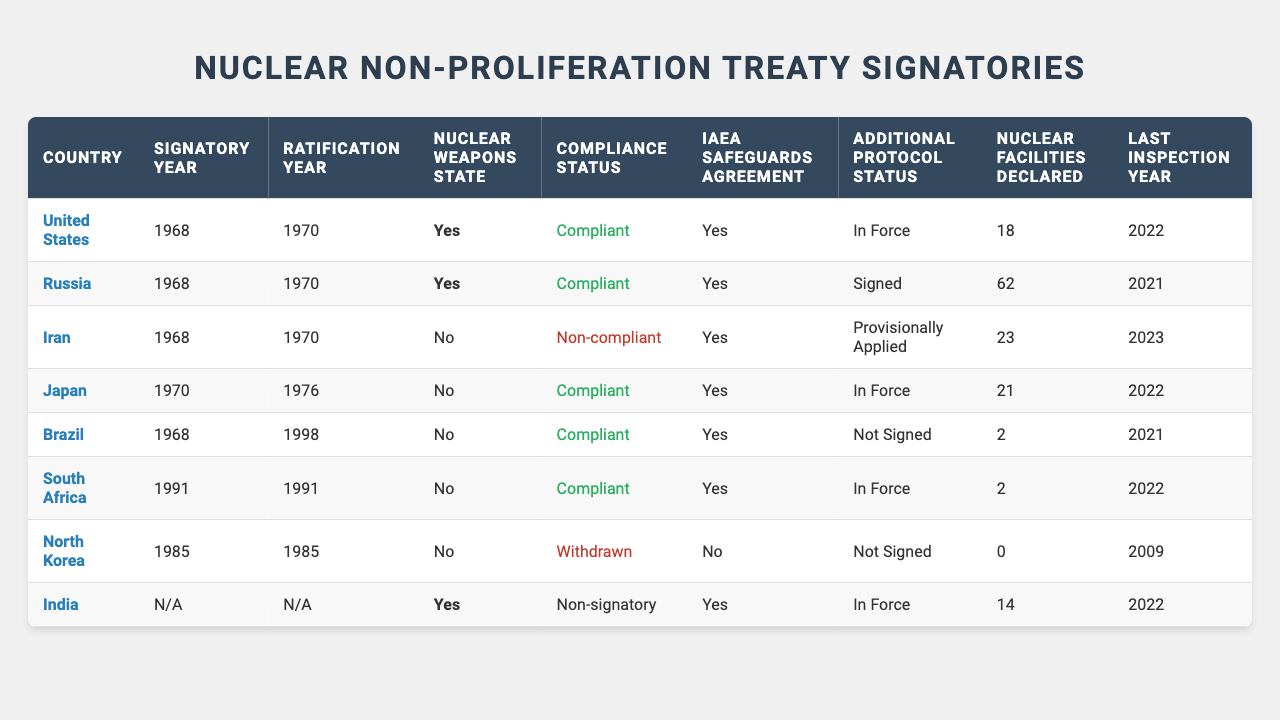What year did North Korea sign the Nuclear Non-Proliferation Treaty? According to the table, North Korea signed the treaty in 1985.
Answer: 1985 How many nuclear facilities are declared by Russia? The table shows that Russia has declared 62 nuclear facilities.
Answer: 62 Is Japan a nuclear weapons state? The table indicates that Japan is not a nuclear weapons state (indicated as No).
Answer: No What is the compliance status of Iran? The table states that Iran's compliance status is "Non-compliant."
Answer: Non-compliant What year was the last inspection conducted for South Africa? According to the table, the last inspection for South Africa was conducted in 2022.
Answer: 2022 Which country has the highest number of nuclear facilities declared? By comparing the data, Russia has the highest number of declared nuclear facilities with 62.
Answer: Russia How many countries in the table are non-compliant? The table shows 2 countries that are non-compliant: Iran and North Korea.
Answer: 2 Which countries have an additional protocol status of 'In Force'? From the table, the countries with 'In Force' additional protocol status are the United States, Japan, and South Africa.
Answer: United States, Japan, South Africa Is there a nuclear weapons state that is non-signatory to the treaty? The table indicates that India, a nuclear weapons state, is a non-signatory to the treaty (no signatory year listed).
Answer: Yes What is the average number of nuclear facilities declared among compliant countries? The compliant countries are the United States (18), Russia (62), Japan (21), Brazil (2), and South Africa (2). Adding these gives a total of 105 facilities. There are 5 compliant countries, so the average is 105/5 = 21.
Answer: 21 What is the relationship between compliance status and IAEA safeguards agreement for nuclear weapons states? The table shows that both the United States and Russia (nuclear weapons states) are compliant and have IAEA safeguards agreements in place. On the other hand, India, although a nuclear weapons state, is listed as a non-signatory.
Answer: Compliant with safeguards How many countries signed the treaty in the 1960s? The table shows that there are 4 countries (United States, Russia, Iran, Brazil) that signed the treaty in the 1960s.
Answer: 4 What does the classification of North Korea under 'Withdrawn' signify regarding its nuclear facilities? The 'Withdrawn' status means North Korea is no longer a participant in the treaty, and it has declared 0 nuclear facilities according to the table.
Answer: No facilities declared 